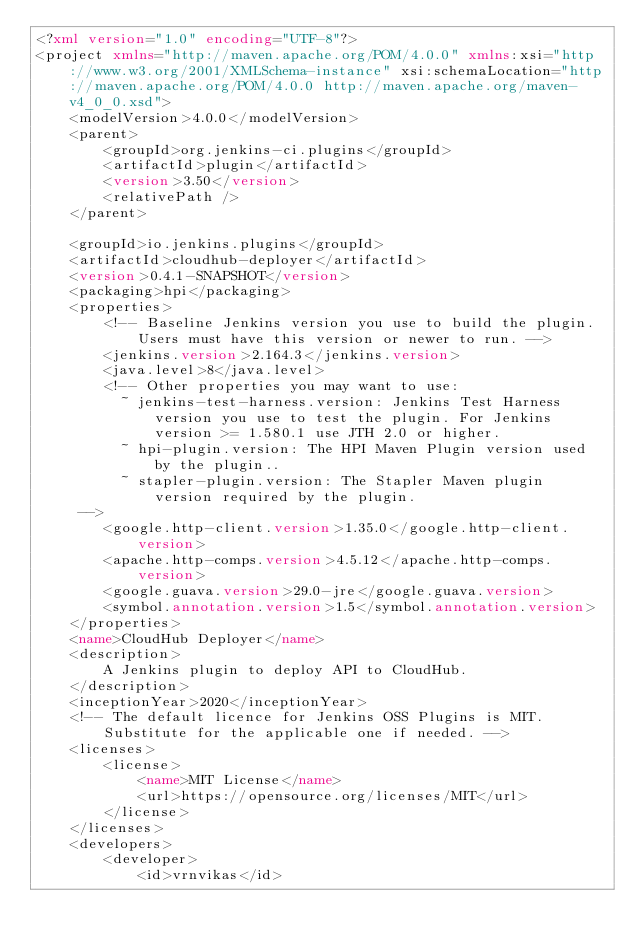<code> <loc_0><loc_0><loc_500><loc_500><_XML_><?xml version="1.0" encoding="UTF-8"?>
<project xmlns="http://maven.apache.org/POM/4.0.0" xmlns:xsi="http://www.w3.org/2001/XMLSchema-instance" xsi:schemaLocation="http://maven.apache.org/POM/4.0.0 http://maven.apache.org/maven-v4_0_0.xsd">
    <modelVersion>4.0.0</modelVersion>
    <parent>
        <groupId>org.jenkins-ci.plugins</groupId>
        <artifactId>plugin</artifactId>
        <version>3.50</version>
        <relativePath />
    </parent>

    <groupId>io.jenkins.plugins</groupId>
    <artifactId>cloudhub-deployer</artifactId>
    <version>0.4.1-SNAPSHOT</version>
    <packaging>hpi</packaging>
    <properties>
        <!-- Baseline Jenkins version you use to build the plugin. Users must have this version or newer to run. -->
        <jenkins.version>2.164.3</jenkins.version>
        <java.level>8</java.level>
        <!-- Other properties you may want to use:
          ~ jenkins-test-harness.version: Jenkins Test Harness version you use to test the plugin. For Jenkins version >= 1.580.1 use JTH 2.0 or higher.
          ~ hpi-plugin.version: The HPI Maven Plugin version used by the plugin..
          ~ stapler-plugin.version: The Stapler Maven plugin version required by the plugin.
     -->
        <google.http-client.version>1.35.0</google.http-client.version>
        <apache.http-comps.version>4.5.12</apache.http-comps.version>
        <google.guava.version>29.0-jre</google.guava.version>
        <symbol.annotation.version>1.5</symbol.annotation.version>
    </properties>
    <name>CloudHub Deployer</name>
    <description>
        A Jenkins plugin to deploy API to CloudHub.
    </description>
    <inceptionYear>2020</inceptionYear>
    <!-- The default licence for Jenkins OSS Plugins is MIT. Substitute for the applicable one if needed. -->
    <licenses>
        <license>
            <name>MIT License</name>
            <url>https://opensource.org/licenses/MIT</url>
        </license>
    </licenses>
    <developers>
        <developer>
            <id>vrnvikas</id></code> 